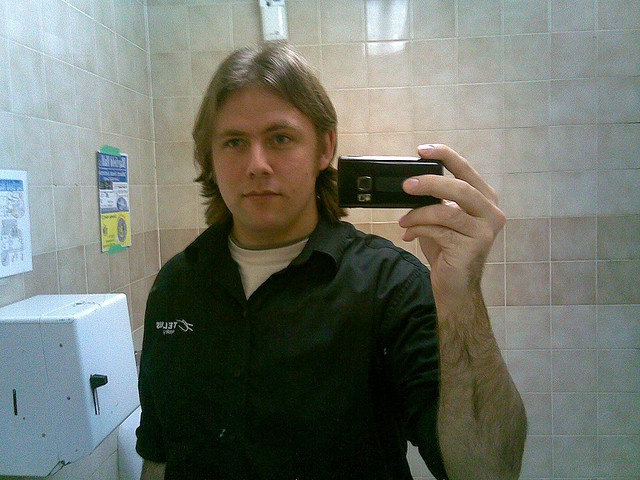Describe the objects in this image and their specific colors. I can see people in lavender, black, olive, and gray tones and cell phone in lavender, black, white, gray, and olive tones in this image. 